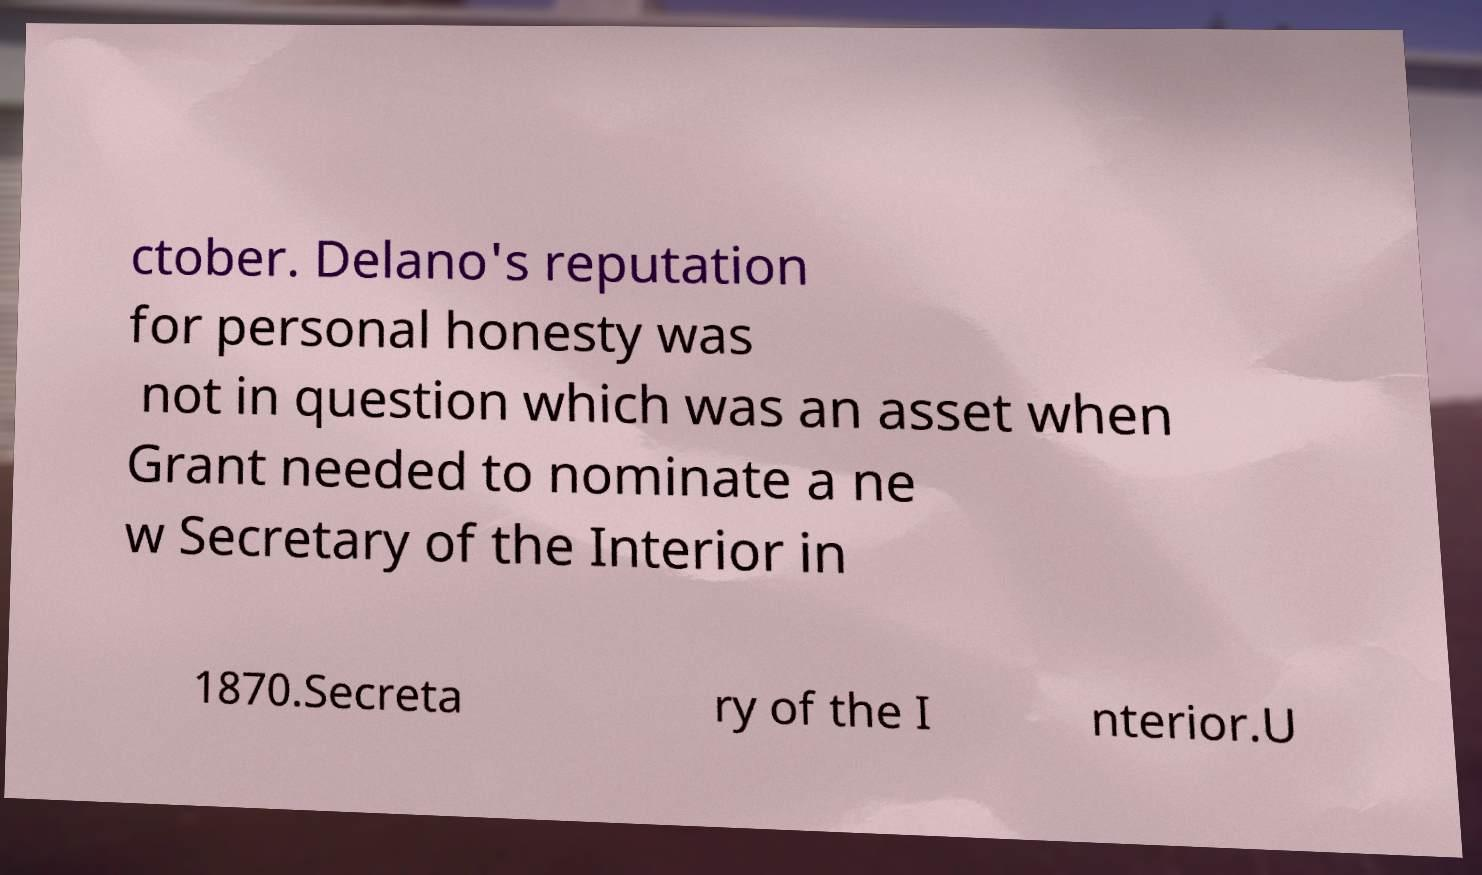Please read and relay the text visible in this image. What does it say? ctober. Delano's reputation for personal honesty was not in question which was an asset when Grant needed to nominate a ne w Secretary of the Interior in 1870.Secreta ry of the I nterior.U 